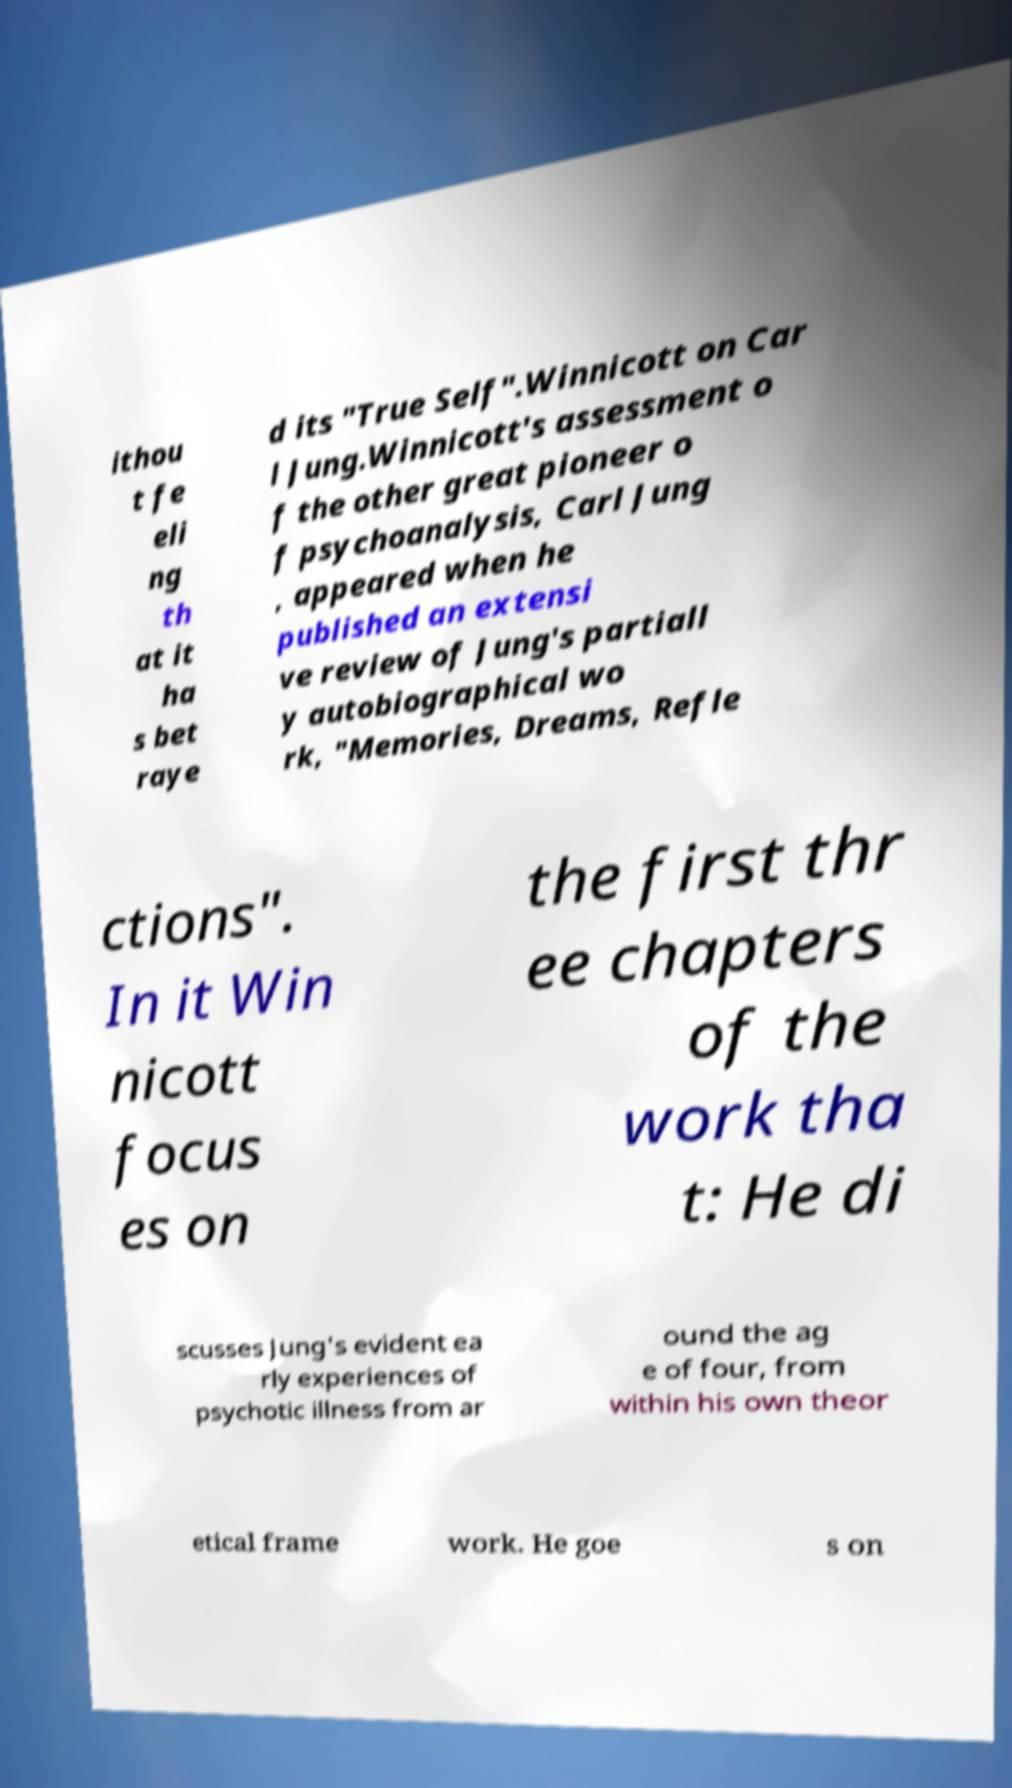Can you read and provide the text displayed in the image?This photo seems to have some interesting text. Can you extract and type it out for me? ithou t fe eli ng th at it ha s bet raye d its "True Self".Winnicott on Car l Jung.Winnicott's assessment o f the other great pioneer o f psychoanalysis, Carl Jung , appeared when he published an extensi ve review of Jung's partiall y autobiographical wo rk, "Memories, Dreams, Refle ctions". In it Win nicott focus es on the first thr ee chapters of the work tha t: He di scusses Jung's evident ea rly experiences of psychotic illness from ar ound the ag e of four, from within his own theor etical frame work. He goe s on 